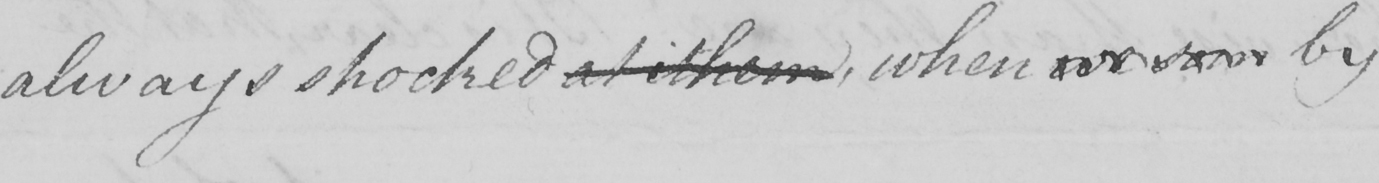Can you read and transcribe this handwriting? always shocked at ithem , when we som by 